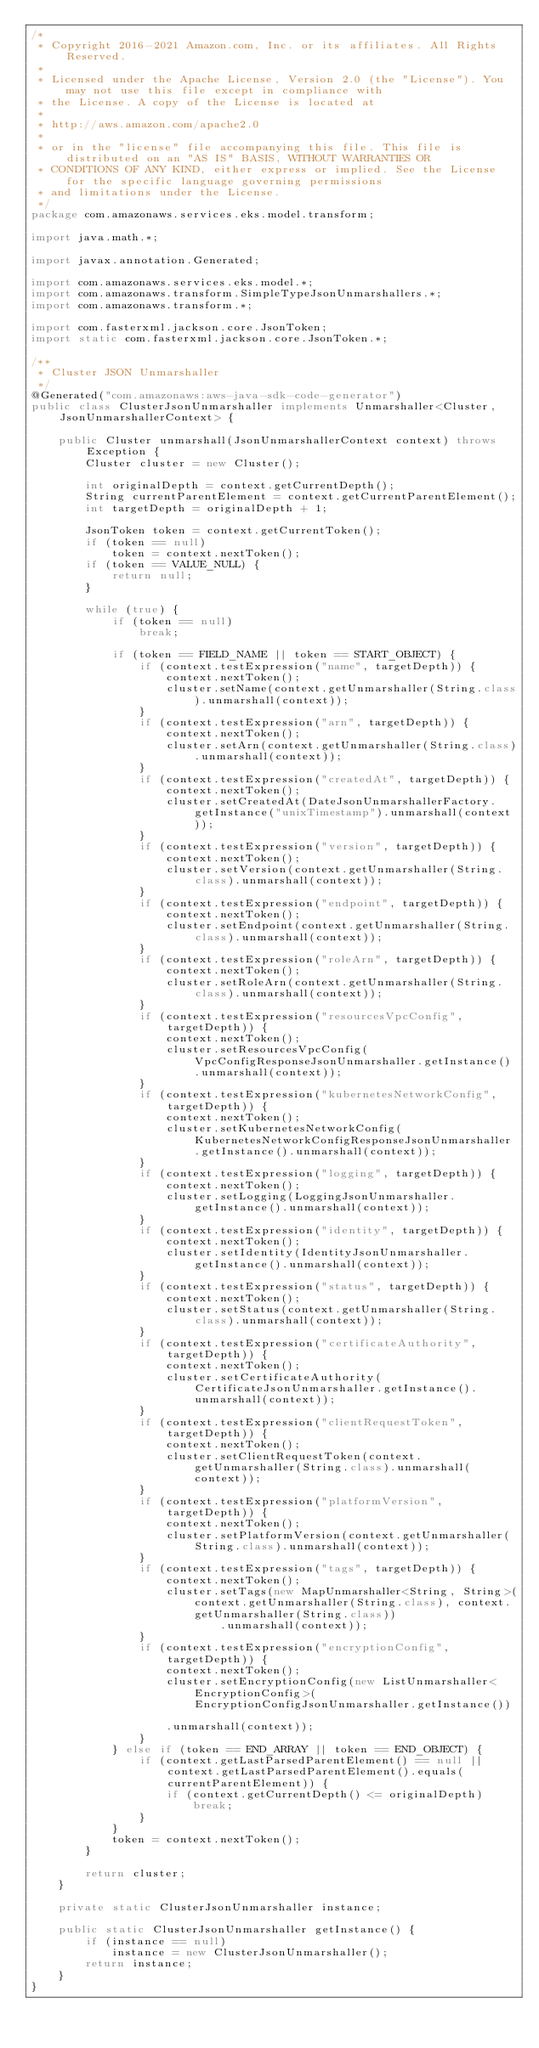<code> <loc_0><loc_0><loc_500><loc_500><_Java_>/*
 * Copyright 2016-2021 Amazon.com, Inc. or its affiliates. All Rights Reserved.
 * 
 * Licensed under the Apache License, Version 2.0 (the "License"). You may not use this file except in compliance with
 * the License. A copy of the License is located at
 * 
 * http://aws.amazon.com/apache2.0
 * 
 * or in the "license" file accompanying this file. This file is distributed on an "AS IS" BASIS, WITHOUT WARRANTIES OR
 * CONDITIONS OF ANY KIND, either express or implied. See the License for the specific language governing permissions
 * and limitations under the License.
 */
package com.amazonaws.services.eks.model.transform;

import java.math.*;

import javax.annotation.Generated;

import com.amazonaws.services.eks.model.*;
import com.amazonaws.transform.SimpleTypeJsonUnmarshallers.*;
import com.amazonaws.transform.*;

import com.fasterxml.jackson.core.JsonToken;
import static com.fasterxml.jackson.core.JsonToken.*;

/**
 * Cluster JSON Unmarshaller
 */
@Generated("com.amazonaws:aws-java-sdk-code-generator")
public class ClusterJsonUnmarshaller implements Unmarshaller<Cluster, JsonUnmarshallerContext> {

    public Cluster unmarshall(JsonUnmarshallerContext context) throws Exception {
        Cluster cluster = new Cluster();

        int originalDepth = context.getCurrentDepth();
        String currentParentElement = context.getCurrentParentElement();
        int targetDepth = originalDepth + 1;

        JsonToken token = context.getCurrentToken();
        if (token == null)
            token = context.nextToken();
        if (token == VALUE_NULL) {
            return null;
        }

        while (true) {
            if (token == null)
                break;

            if (token == FIELD_NAME || token == START_OBJECT) {
                if (context.testExpression("name", targetDepth)) {
                    context.nextToken();
                    cluster.setName(context.getUnmarshaller(String.class).unmarshall(context));
                }
                if (context.testExpression("arn", targetDepth)) {
                    context.nextToken();
                    cluster.setArn(context.getUnmarshaller(String.class).unmarshall(context));
                }
                if (context.testExpression("createdAt", targetDepth)) {
                    context.nextToken();
                    cluster.setCreatedAt(DateJsonUnmarshallerFactory.getInstance("unixTimestamp").unmarshall(context));
                }
                if (context.testExpression("version", targetDepth)) {
                    context.nextToken();
                    cluster.setVersion(context.getUnmarshaller(String.class).unmarshall(context));
                }
                if (context.testExpression("endpoint", targetDepth)) {
                    context.nextToken();
                    cluster.setEndpoint(context.getUnmarshaller(String.class).unmarshall(context));
                }
                if (context.testExpression("roleArn", targetDepth)) {
                    context.nextToken();
                    cluster.setRoleArn(context.getUnmarshaller(String.class).unmarshall(context));
                }
                if (context.testExpression("resourcesVpcConfig", targetDepth)) {
                    context.nextToken();
                    cluster.setResourcesVpcConfig(VpcConfigResponseJsonUnmarshaller.getInstance().unmarshall(context));
                }
                if (context.testExpression("kubernetesNetworkConfig", targetDepth)) {
                    context.nextToken();
                    cluster.setKubernetesNetworkConfig(KubernetesNetworkConfigResponseJsonUnmarshaller.getInstance().unmarshall(context));
                }
                if (context.testExpression("logging", targetDepth)) {
                    context.nextToken();
                    cluster.setLogging(LoggingJsonUnmarshaller.getInstance().unmarshall(context));
                }
                if (context.testExpression("identity", targetDepth)) {
                    context.nextToken();
                    cluster.setIdentity(IdentityJsonUnmarshaller.getInstance().unmarshall(context));
                }
                if (context.testExpression("status", targetDepth)) {
                    context.nextToken();
                    cluster.setStatus(context.getUnmarshaller(String.class).unmarshall(context));
                }
                if (context.testExpression("certificateAuthority", targetDepth)) {
                    context.nextToken();
                    cluster.setCertificateAuthority(CertificateJsonUnmarshaller.getInstance().unmarshall(context));
                }
                if (context.testExpression("clientRequestToken", targetDepth)) {
                    context.nextToken();
                    cluster.setClientRequestToken(context.getUnmarshaller(String.class).unmarshall(context));
                }
                if (context.testExpression("platformVersion", targetDepth)) {
                    context.nextToken();
                    cluster.setPlatformVersion(context.getUnmarshaller(String.class).unmarshall(context));
                }
                if (context.testExpression("tags", targetDepth)) {
                    context.nextToken();
                    cluster.setTags(new MapUnmarshaller<String, String>(context.getUnmarshaller(String.class), context.getUnmarshaller(String.class))
                            .unmarshall(context));
                }
                if (context.testExpression("encryptionConfig", targetDepth)) {
                    context.nextToken();
                    cluster.setEncryptionConfig(new ListUnmarshaller<EncryptionConfig>(EncryptionConfigJsonUnmarshaller.getInstance())

                    .unmarshall(context));
                }
            } else if (token == END_ARRAY || token == END_OBJECT) {
                if (context.getLastParsedParentElement() == null || context.getLastParsedParentElement().equals(currentParentElement)) {
                    if (context.getCurrentDepth() <= originalDepth)
                        break;
                }
            }
            token = context.nextToken();
        }

        return cluster;
    }

    private static ClusterJsonUnmarshaller instance;

    public static ClusterJsonUnmarshaller getInstance() {
        if (instance == null)
            instance = new ClusterJsonUnmarshaller();
        return instance;
    }
}
</code> 